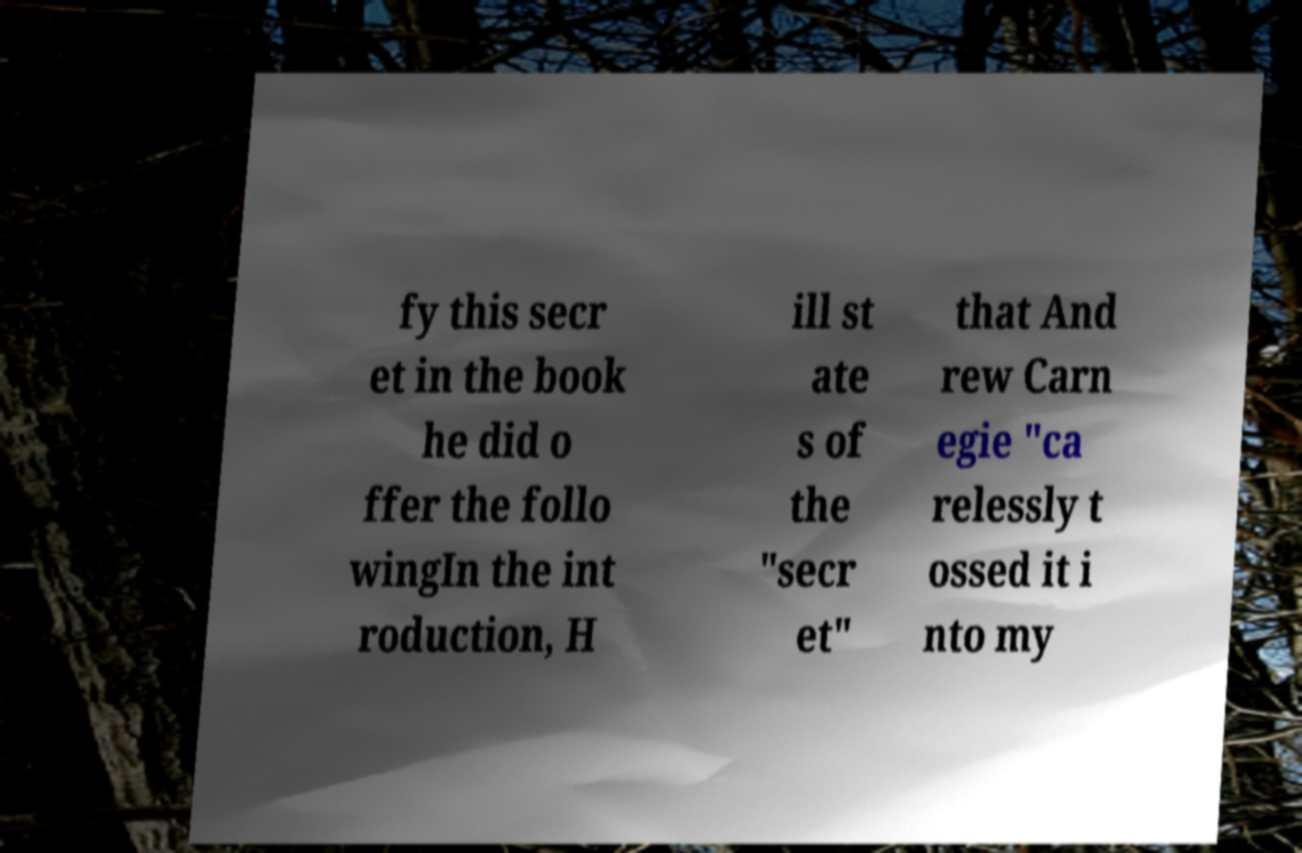Could you extract and type out the text from this image? fy this secr et in the book he did o ffer the follo wingIn the int roduction, H ill st ate s of the "secr et" that And rew Carn egie "ca relessly t ossed it i nto my 